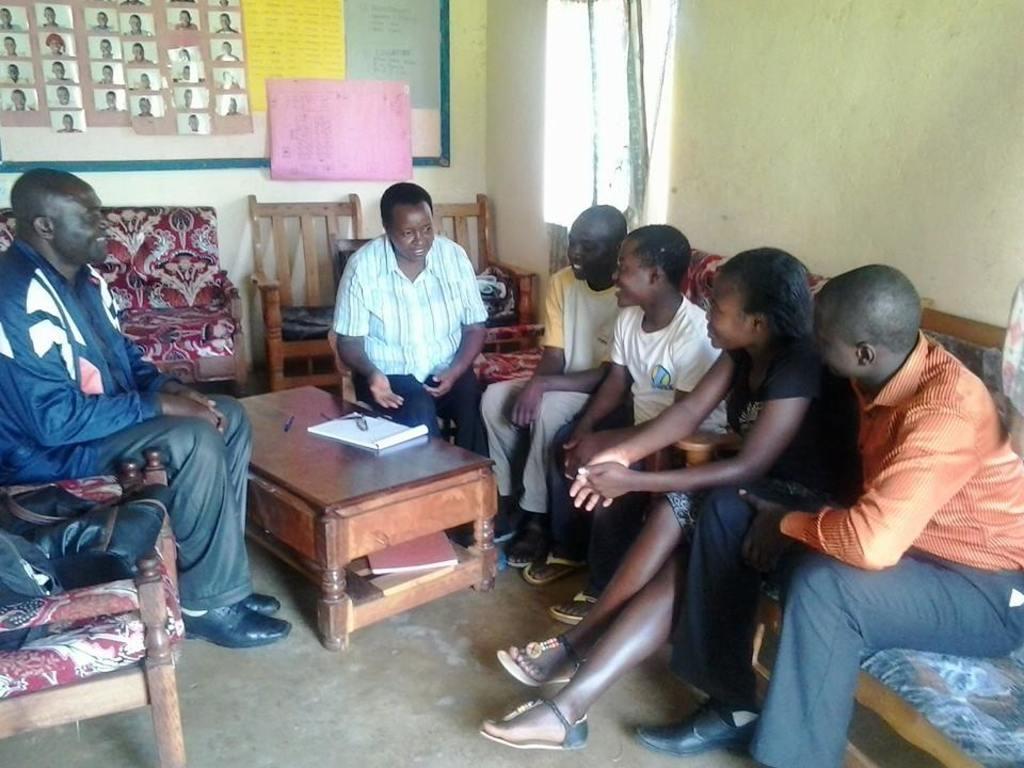Describe this image in one or two sentences. Here we can see a group of people are sitting, and in front here is the table and book on it, and here are the chairs, and here is the wall and pictures on it. 